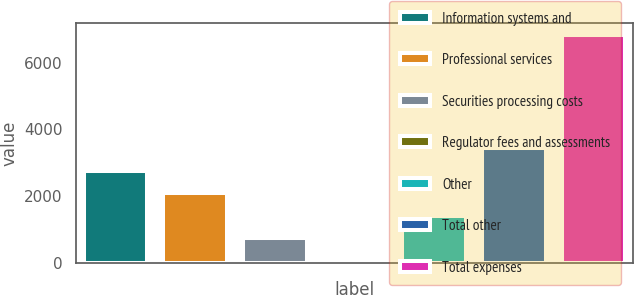Convert chart to OTSL. <chart><loc_0><loc_0><loc_500><loc_500><bar_chart><fcel>Information systems and<fcel>Professional services<fcel>Securities processing costs<fcel>Regulator fees and assessments<fcel>Other<fcel>Total other<fcel>Total expenses<nl><fcel>2768<fcel>2089<fcel>731<fcel>52<fcel>1410<fcel>3447<fcel>6842<nl></chart> 